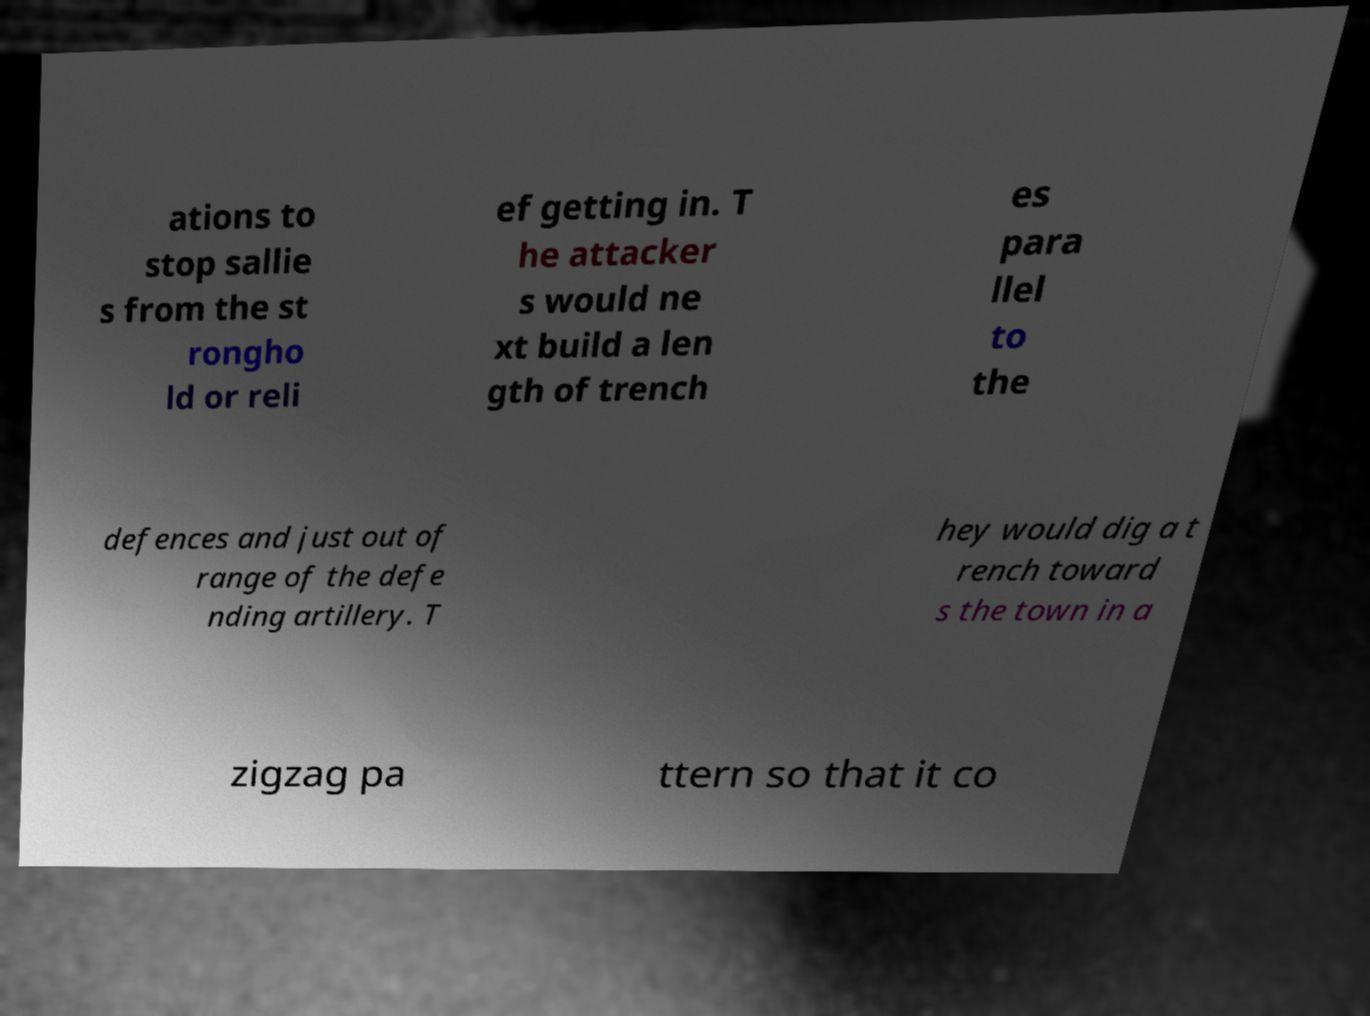Could you assist in decoding the text presented in this image and type it out clearly? ations to stop sallie s from the st rongho ld or reli ef getting in. T he attacker s would ne xt build a len gth of trench es para llel to the defences and just out of range of the defe nding artillery. T hey would dig a t rench toward s the town in a zigzag pa ttern so that it co 